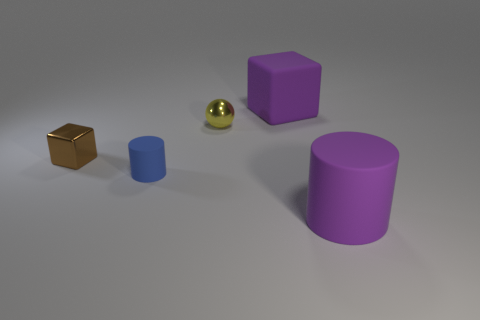What size is the rubber cylinder that is the same color as the matte cube?
Make the answer very short. Large. There is a small sphere; are there any blue objects to the left of it?
Provide a succinct answer. Yes. Does the block that is to the left of the blue cylinder have the same size as the rubber cylinder on the right side of the blue cylinder?
Your answer should be compact. No. Is there a yellow object that has the same size as the blue matte cylinder?
Make the answer very short. Yes. Does the big thing behind the brown object have the same shape as the tiny blue matte object?
Make the answer very short. No. What is the material of the purple thing in front of the purple rubber cube?
Give a very brief answer. Rubber. What is the shape of the tiny metal object to the left of the shiny object behind the tiny brown cube?
Your answer should be compact. Cube. Do the tiny matte thing and the purple matte thing in front of the brown object have the same shape?
Offer a terse response. Yes. What number of spheres are on the left side of the purple object that is in front of the rubber block?
Ensure brevity in your answer.  1. There is a purple thing that is the same shape as the tiny blue object; what is it made of?
Provide a succinct answer. Rubber. 